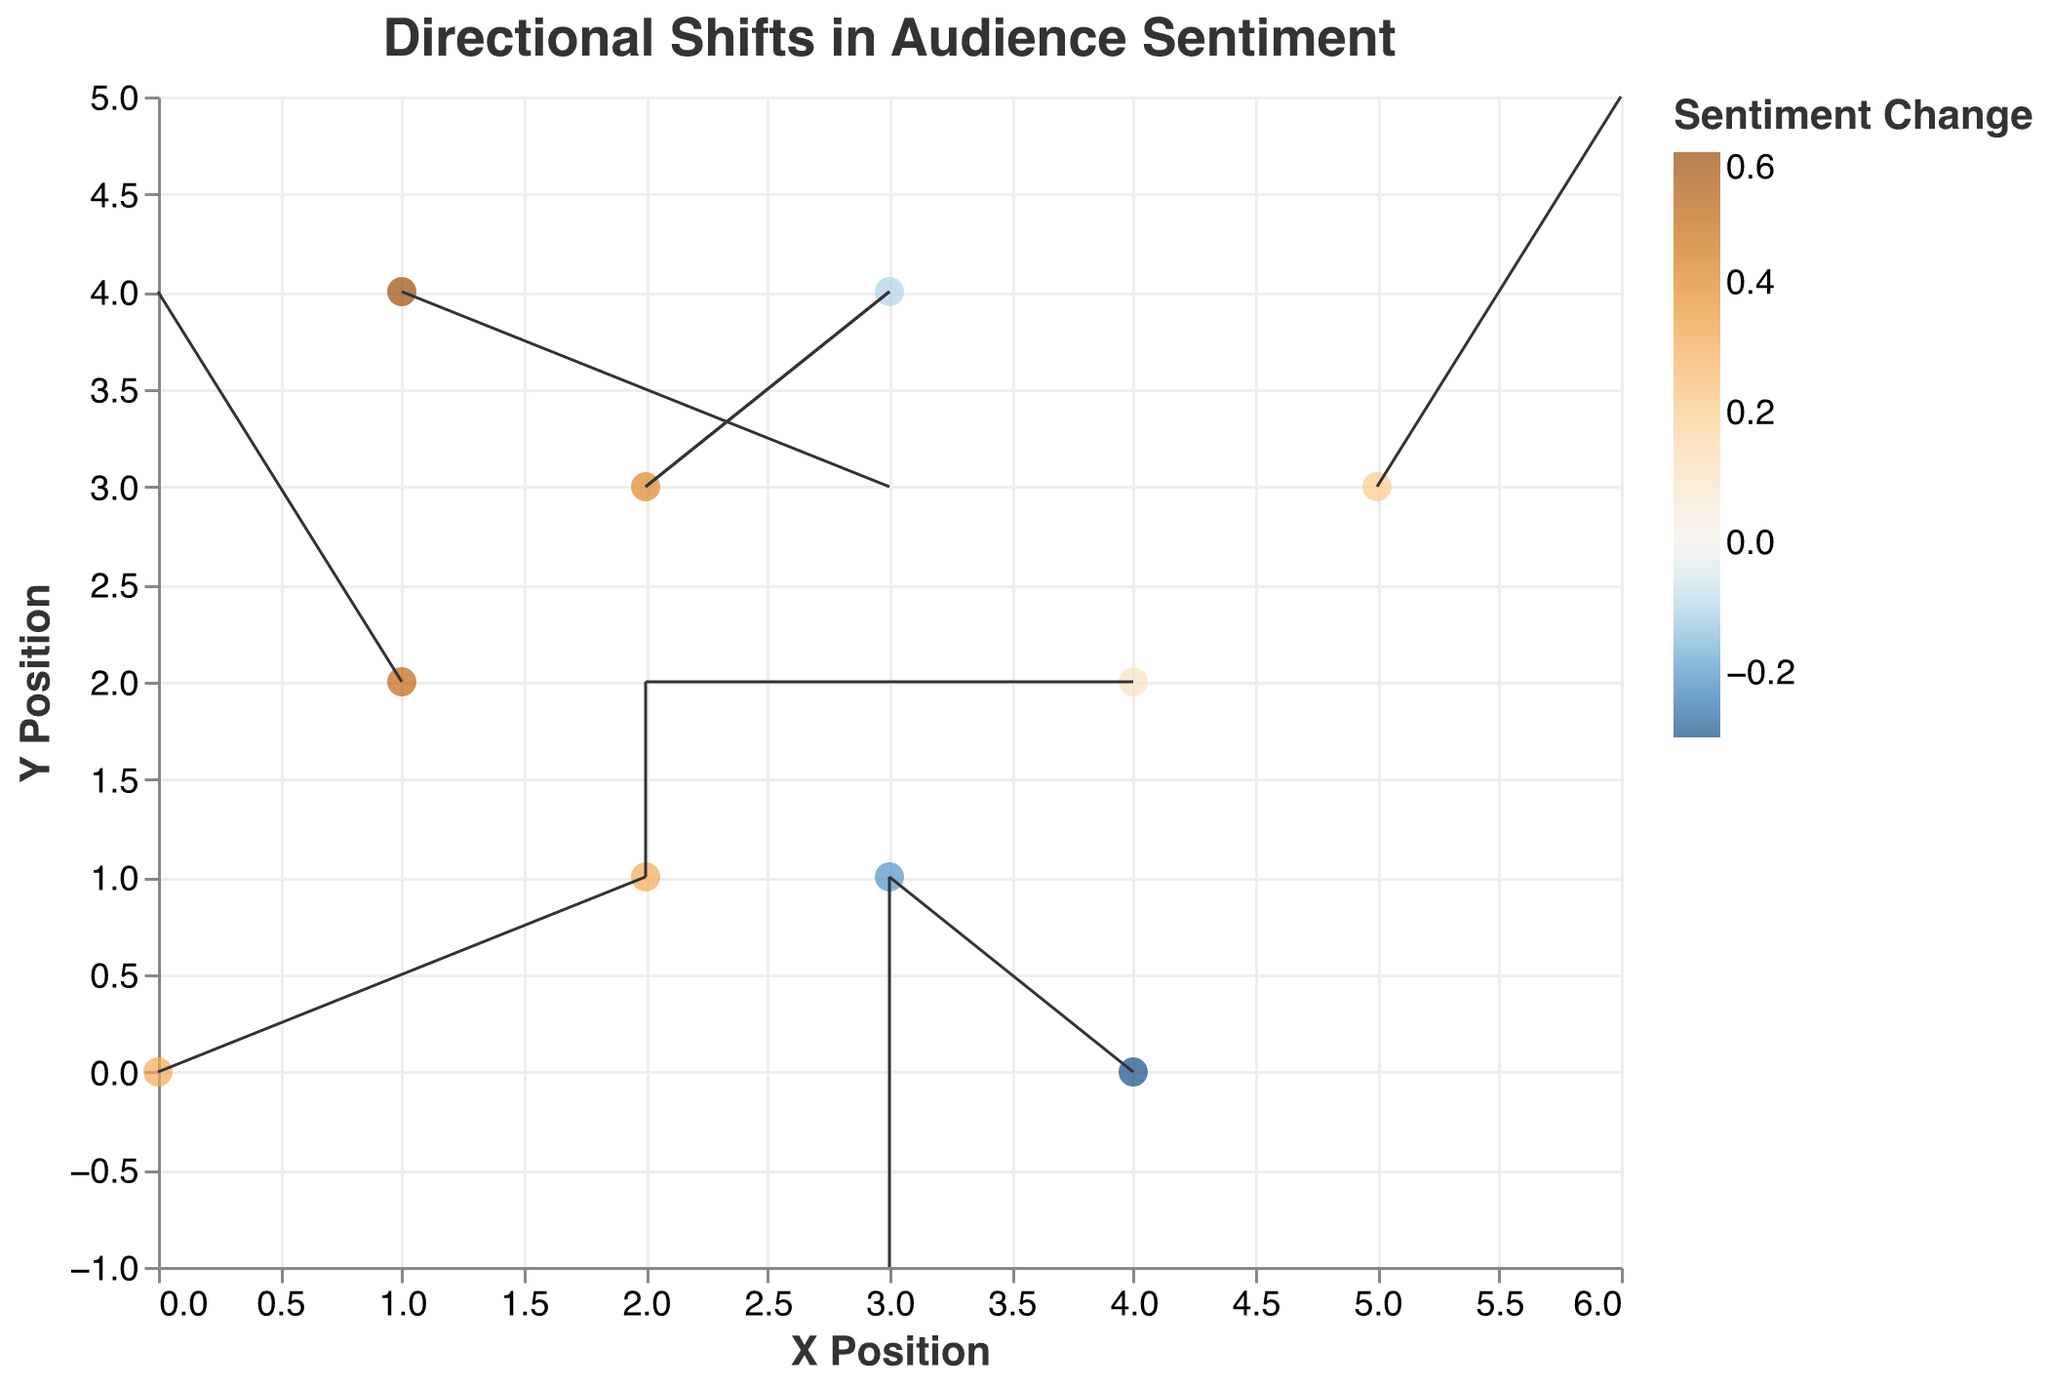What is the title of the plot? The title can be seen at the top of the plot. It reads "Directional Shifts in Audience Sentiment" which describes the purpose of the quiver plot.
Answer: Directional Shifts in Audience Sentiment How many different content types are shown in the plot? Counting the unique content types listed in the tooltip associated with each data point will give the number. There are Instagram post, YouTube video, TikTok challenge, Blog article, Twitter thread, Facebook live, Podcast episode, LinkedIn post, Pinterest pin, and Email newsletter.
Answer: 10 Which content type has the highest sentiment change and what is its value? By observing the color coding and tooltips, we identify that the "Facebook live" has the highest sentiment change with a value of 0.6.
Answer: Facebook live, 0.6 In which direction does the TikTok challenge content type shift? Referring to the quiver arrows for TikTok challenge, it has coordinates (3, 1) and a direction vector of (0, -2). This indicates the shift is two units downward.
Answer: Downward Which content type has experienced a negative sentiment change, and what are their specific values? By looking at the color coding and tooltips, we find that TikTok challenge (-0.2), Podcast episode (-0.1), and Email newsletter (-0.3) experienced negative sentiment changes.
Answer: TikTok challenge (-0.2), Podcast episode (-0.1), Email newsletter (-0.3) What is the average sentiment change across all content types? Summing up all sentiment changes (0.3, 0.5, -0.2, 0.4, 0.1, 0.6, -0.1, 0.2, 0.3, -0.3) gives a total of 1.8. Dividing by the number of data points (10) results in an average sentiment change of 1.8/10.
Answer: 0.18 Which content type has the largest horizontal shift and what is the magnitude of this shift? Examining the 'u' component of the vectors, the content types "Instagram post" and "Twitter thread" both have a horizontal shift of magnitude 2.
Answer: Instagram post, Twitter thread; 2 Compare the sentiment changes for Instagram post and YouTube video. Which one has a higher value? Referring to the color coding and tooltips, the sentiment change for Instagram post is 0.3, while YouTube video has a sentiment change of 0.5. Thus, YouTube video has a higher sentiment change.
Answer: YouTube video What is the overall direction trend for most of the content types? Analyzing the direction of the vectors, most content types exhibit shifts either upward or to the right, indicating a generally positive sentiment or engagement direction.
Answer: Upward/Rightward 